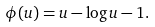Convert formula to latex. <formula><loc_0><loc_0><loc_500><loc_500>\phi ( u ) = u - \log u - 1 .</formula> 